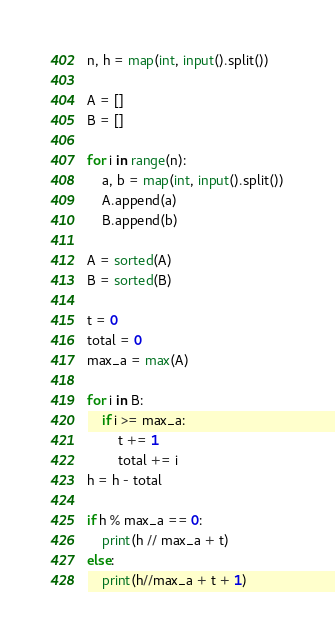<code> <loc_0><loc_0><loc_500><loc_500><_Python_>n, h = map(int, input().split())

A = []
B = []

for i in range(n):
    a, b = map(int, input().split())
    A.append(a)
    B.append(b)

A = sorted(A)
B = sorted(B)

t = 0
total = 0
max_a = max(A)

for i in B:
    if i >= max_a:
        t += 1
        total += i
h = h - total

if h % max_a == 0:
    print(h // max_a + t)
else:
    print(h//max_a + t + 1)</code> 